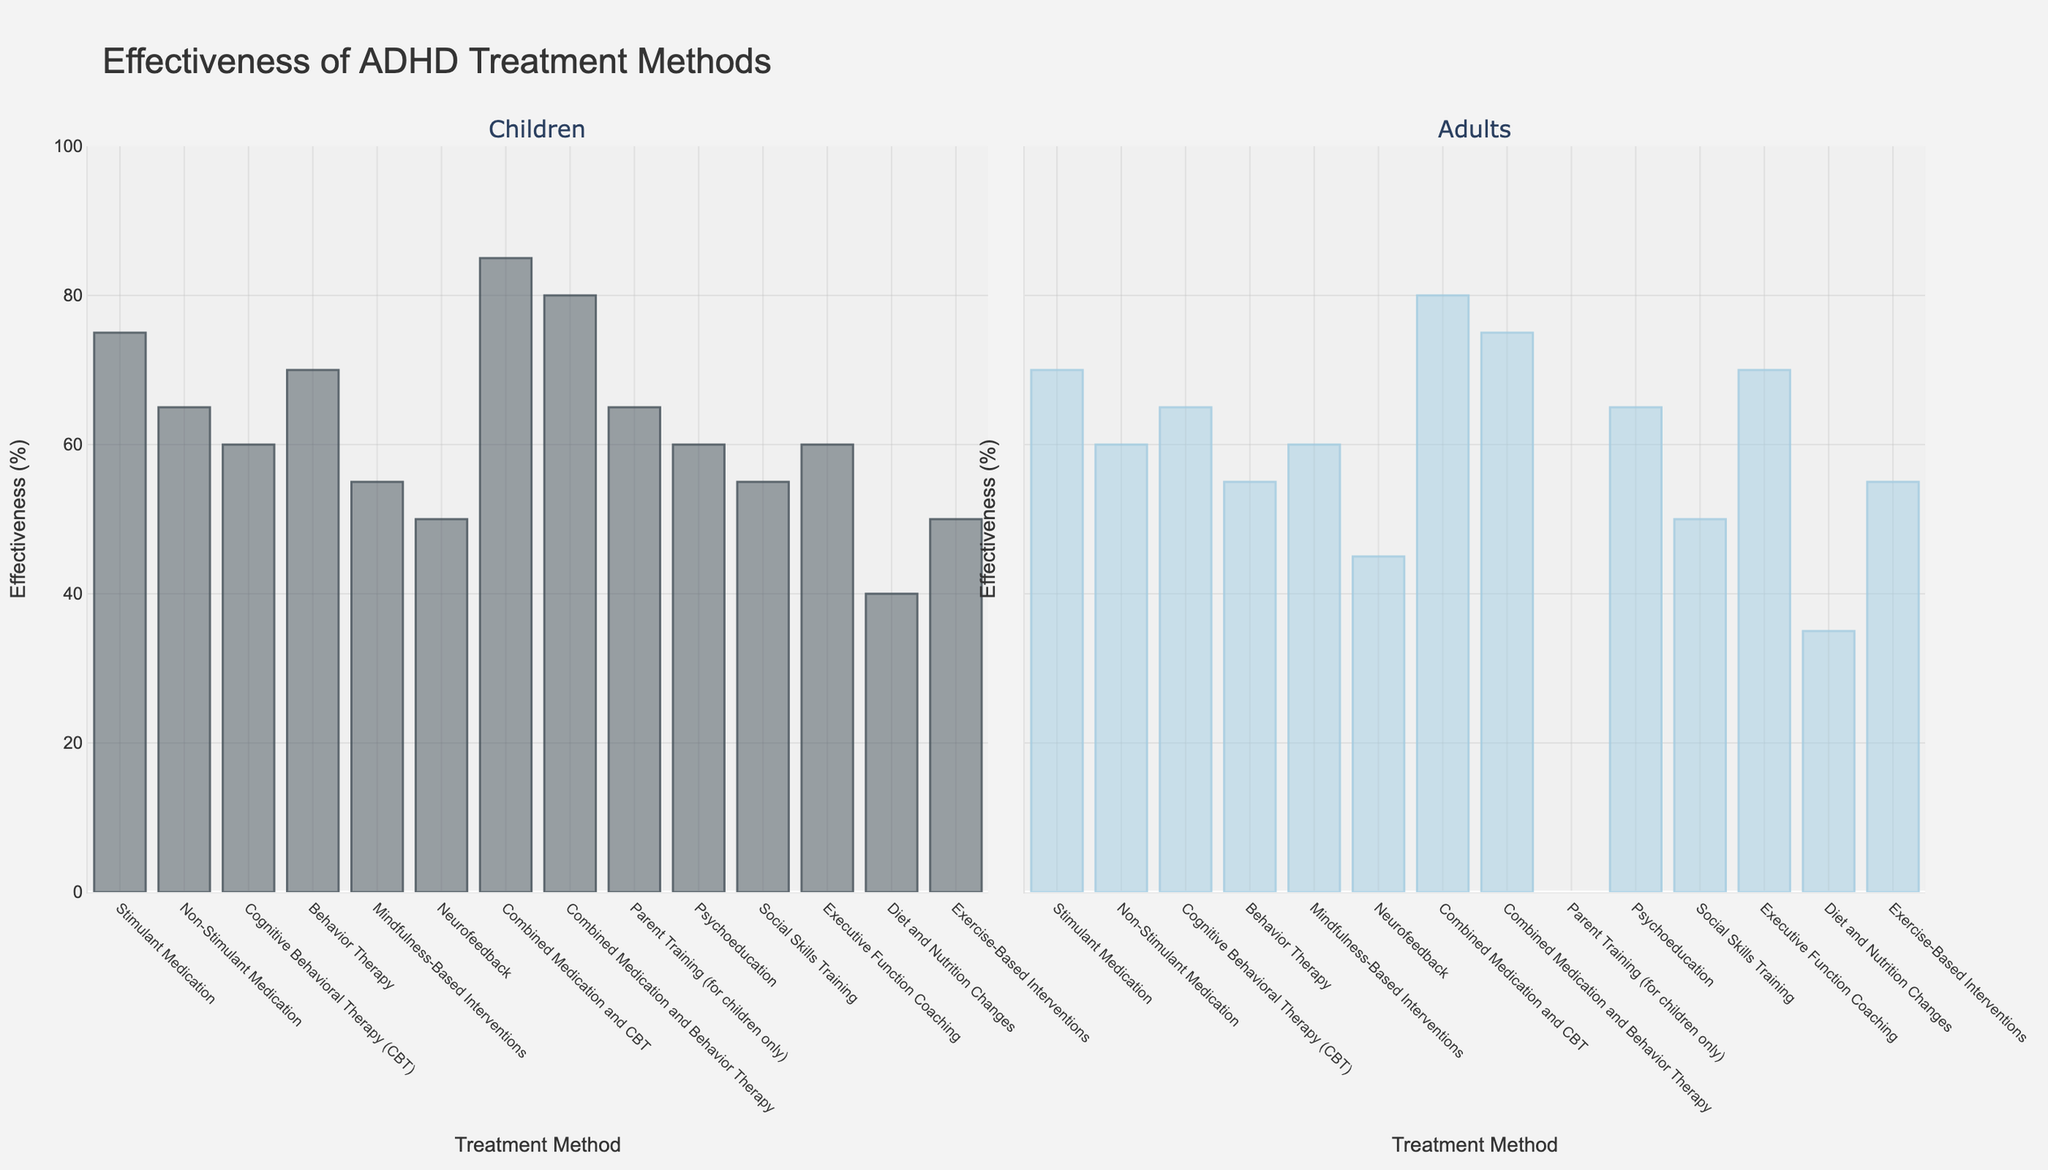Which ADHD treatment method has the highest effectiveness in children? Look at the height of the bars in the children's subplot. The tallest bar represents the most effective treatment method for children.
Answer: Combined Medication and CBT Which treatment methods have the same effectiveness percentage in adults? Compare the heights of bars in the adults’ subplot. Those that reach the same height have the same effectiveness percentage.
Answer: CBT, Mindfulness-Based Interventions, and Psychoeducation What is the difference in effectiveness of Stimulant Medication between children and adults? Find the height of the bar for Stimulant Medication in the children’s subplot and subtract it from the height of the corresponding bar in the adults’ subplot.
Answer: 5% Which approach is more effective for adults, Behavioral Therapy or Mindfulness-Based Interventions? Compare the heights of the bars for Behavioral Therapy and Mindfulness-Based Interventions in the adults’ subplot.
Answer: Mindfulness-Based Interventions Which treatment method has the lowest effectiveness in children, and what is its effectiveness percentage? Identify the shortest bar in the children’s subplot and note its height to find the effectiveness percentage.
Answer: Diet and Nutrition Changes, 40% By how much is the effectiveness of Combined Medication and CBT greater in children than in adults? Find the height of the Combined Medication and CBT bar in both subplots and subtract the adult value from the children’s value.
Answer: 5% What is the average effectiveness percentage of Non-Stimulant Medication for children and adults? Add the percentages for Non-Stimulant Medication for both children and adults, then divide by 2 to find the average. (65+60)/2 = 62.5
Answer: 62.5 How does the effectiveness of Exercise-Based Interventions compare between children and adults? Compare the heights of the bars for Exercise-Based Interventions in both subplots to see whether children or adults have a higher effectiveness percentage.
Answer: More effective for adults Which treatment methods are more effective for children than for adults? Compare each treatment method's bars between the children’s and adults’ subplots to see which are higher for children.
Answer: Stimulant Medication, Non-Stimulant Medication, Behavior Therapy, Combined Medication and Behavior Therapy, Parent Training, Social Skills Training, Exercise-Based Interventions 